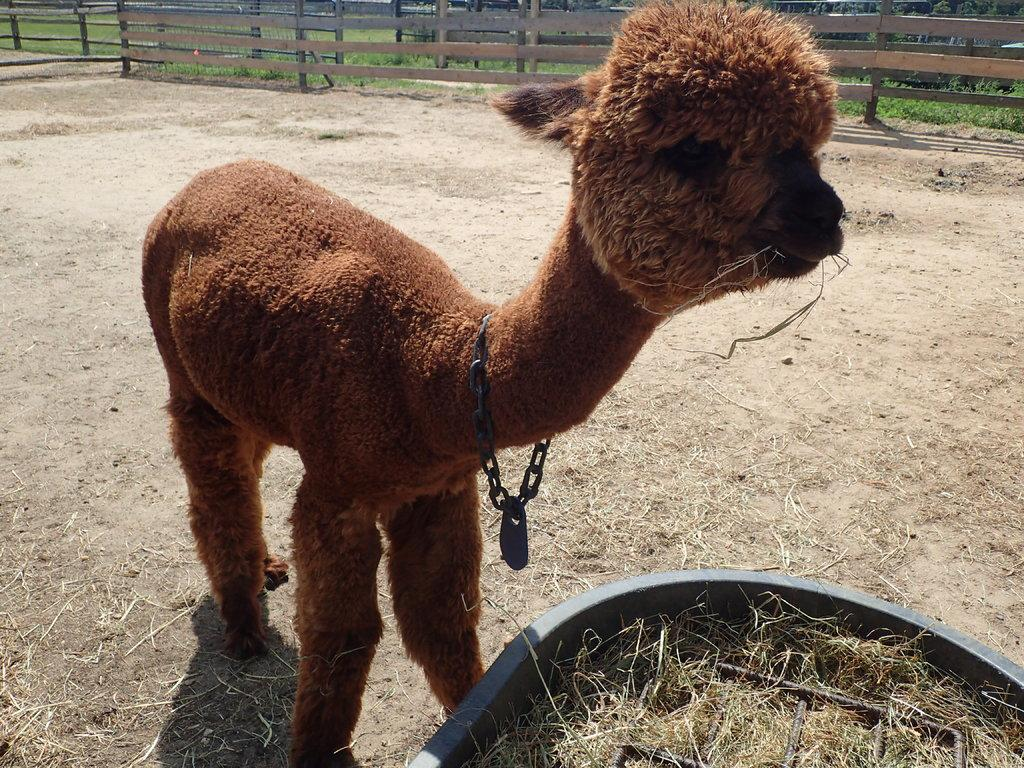What type of animal can be seen on the ground in the image? There is an animal on the ground in the image, but the specific type cannot be determined from the facts provided. What type of vegetation is visible in the image? There is grass visible in the image. What is inside the container in the image? There is a metal object in a container in the image. What can be seen in the background of the image? There is a fence and grass in the background of the image. What is the belief of the animal's sister in the image? There is no mention of a sister or any beliefs in the image. How many bananas are visible in the image? There are no bananas present in the image. 